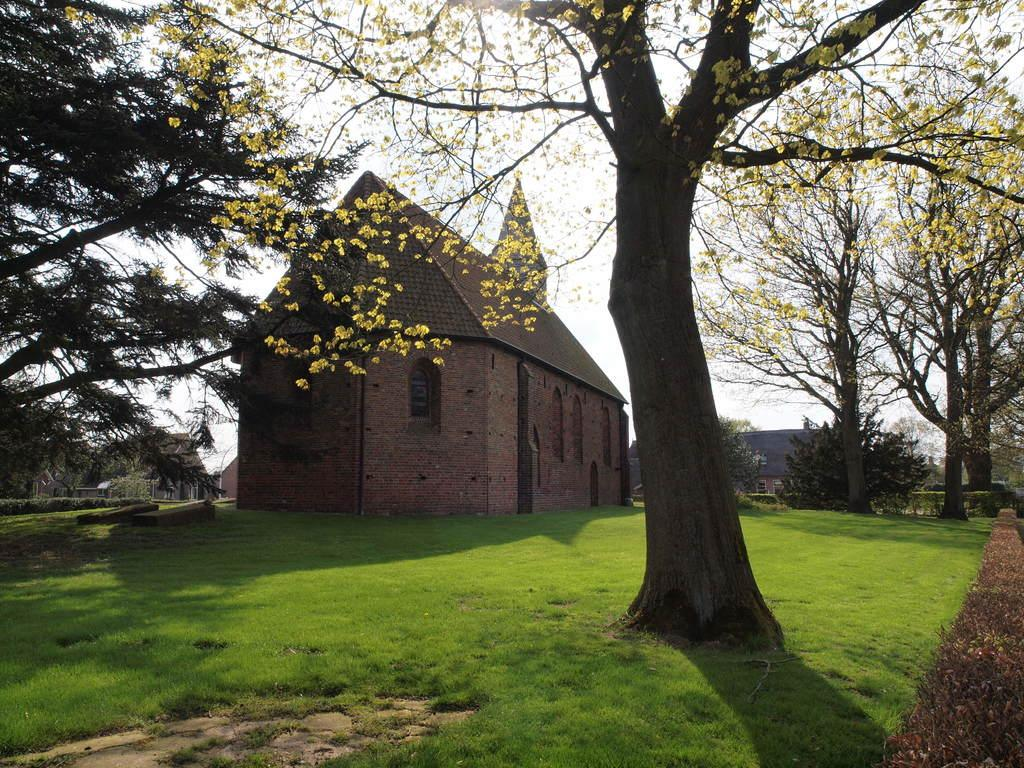What type of vegetation can be seen in the image? There are trees in the image. What is the color of the trees? The trees are green in color. What can be seen in the background of the image? There are buildings in the background of the image. What is the color of the sky in the image? The sky is white in color. What type of iron is being used to carry the basket in the image? There is no iron or basket present in the image. 